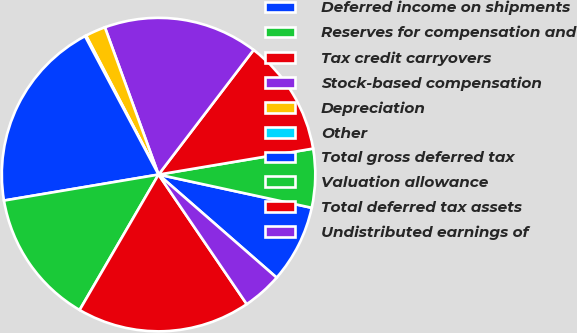Convert chart. <chart><loc_0><loc_0><loc_500><loc_500><pie_chart><fcel>Deferred income on shipments<fcel>Reserves for compensation and<fcel>Tax credit carryovers<fcel>Stock-based compensation<fcel>Depreciation<fcel>Other<fcel>Total gross deferred tax<fcel>Valuation allowance<fcel>Total deferred tax assets<fcel>Undistributed earnings of<nl><fcel>8.02%<fcel>6.05%<fcel>11.98%<fcel>15.93%<fcel>2.09%<fcel>0.12%<fcel>19.88%<fcel>13.95%<fcel>17.91%<fcel>4.07%<nl></chart> 